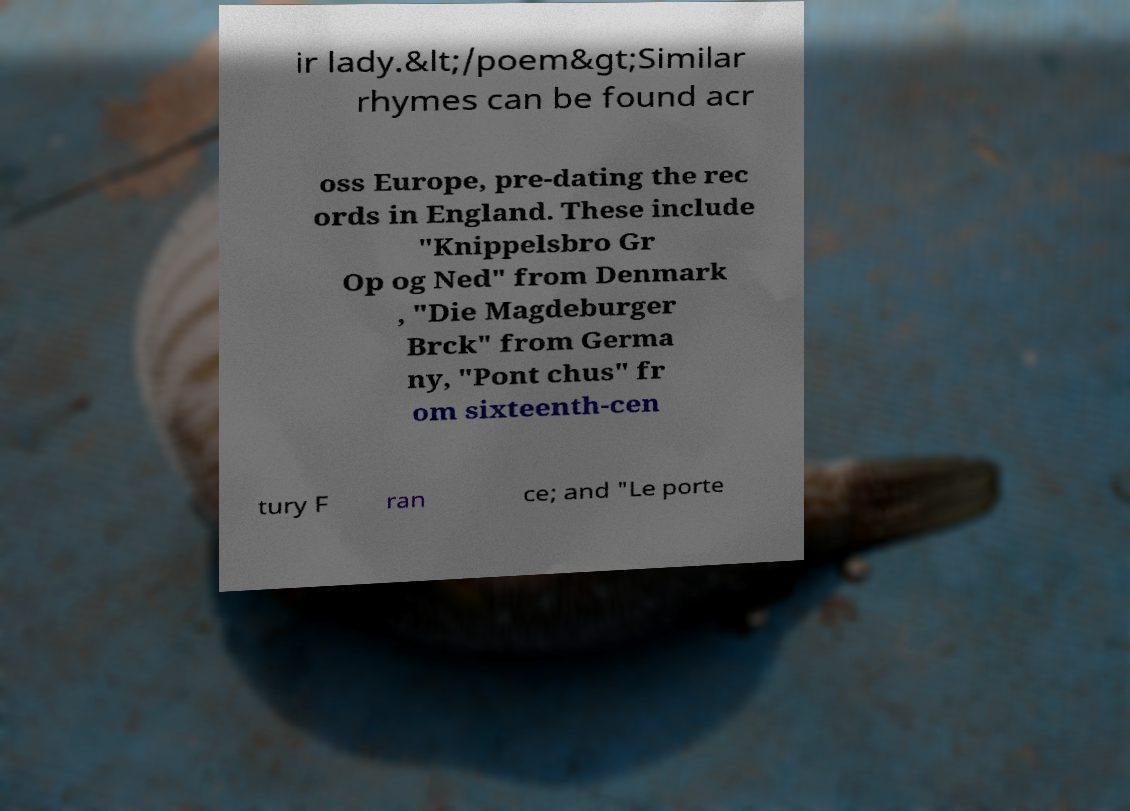There's text embedded in this image that I need extracted. Can you transcribe it verbatim? ir lady.&lt;/poem&gt;Similar rhymes can be found acr oss Europe, pre-dating the rec ords in England. These include "Knippelsbro Gr Op og Ned" from Denmark , "Die Magdeburger Brck" from Germa ny, "Pont chus" fr om sixteenth-cen tury F ran ce; and "Le porte 